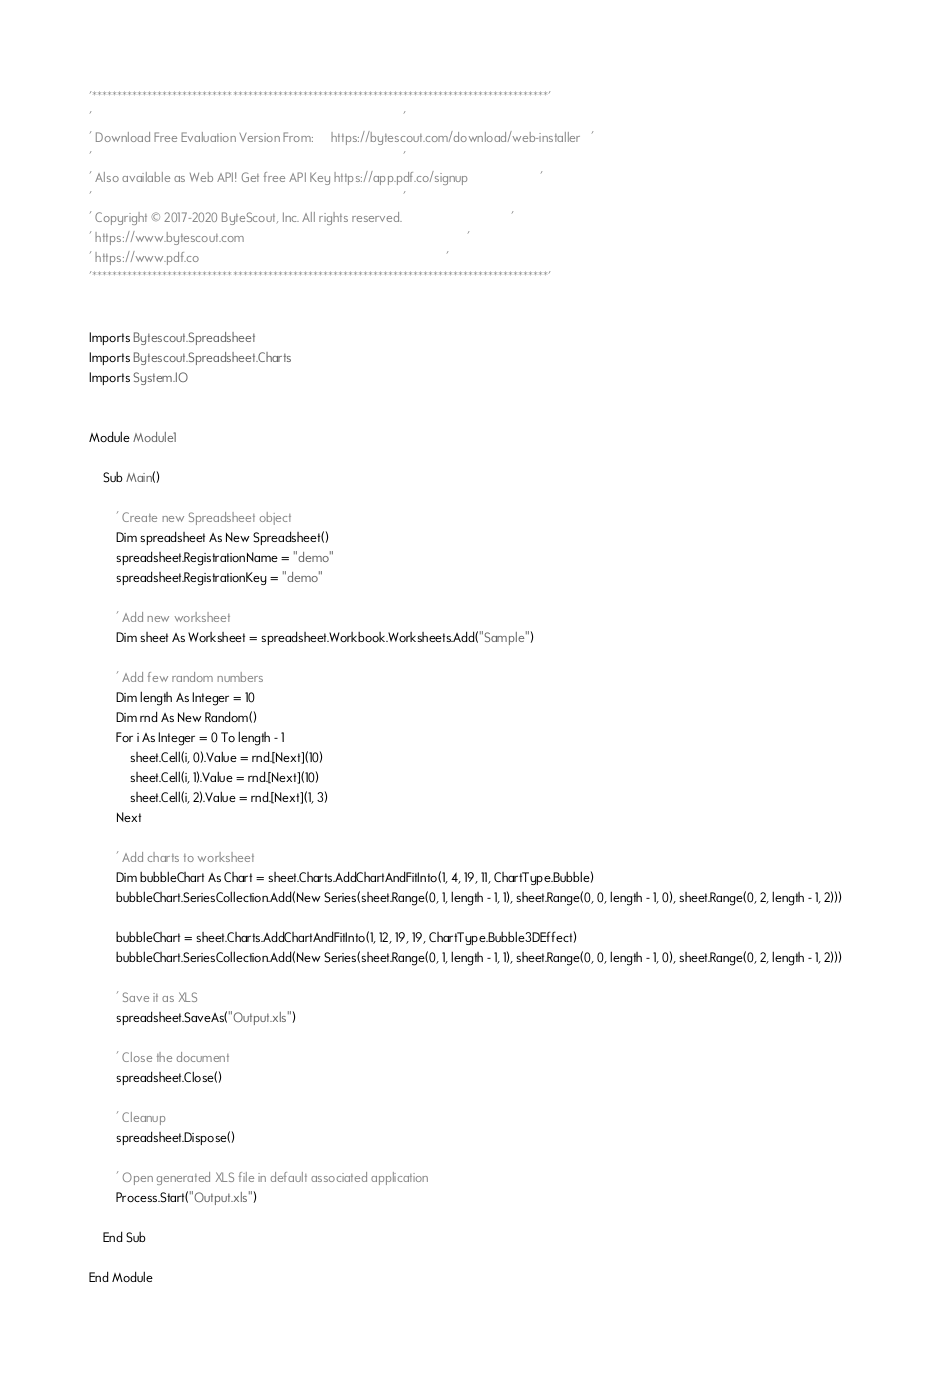Convert code to text. <code><loc_0><loc_0><loc_500><loc_500><_VisualBasic_>'*******************************************************************************************'
'                                                                                           '
' Download Free Evaluation Version From:     https://bytescout.com/download/web-installer   '
'                                                                                           '
' Also available as Web API! Get free API Key https://app.pdf.co/signup                     '
'                                                                                           '
' Copyright © 2017-2020 ByteScout, Inc. All rights reserved.                                '
' https://www.bytescout.com                                                                 '
' https://www.pdf.co                                                                        '
'*******************************************************************************************'


Imports Bytescout.Spreadsheet
Imports Bytescout.Spreadsheet.Charts
Imports System.IO


Module Module1

    Sub Main()

        ' Create new Spreadsheet object
        Dim spreadsheet As New Spreadsheet()
        spreadsheet.RegistrationName = "demo"
        spreadsheet.RegistrationKey = "demo"

        ' Add new worksheet
        Dim sheet As Worksheet = spreadsheet.Workbook.Worksheets.Add("Sample")

        ' Add few random numbers
        Dim length As Integer = 10
        Dim rnd As New Random()
        For i As Integer = 0 To length - 1
            sheet.Cell(i, 0).Value = rnd.[Next](10)
            sheet.Cell(i, 1).Value = rnd.[Next](10)
            sheet.Cell(i, 2).Value = rnd.[Next](1, 3)
        Next

        ' Add charts to worksheet
        Dim bubbleChart As Chart = sheet.Charts.AddChartAndFitInto(1, 4, 19, 11, ChartType.Bubble)
        bubbleChart.SeriesCollection.Add(New Series(sheet.Range(0, 1, length - 1, 1), sheet.Range(0, 0, length - 1, 0), sheet.Range(0, 2, length - 1, 2)))

        bubbleChart = sheet.Charts.AddChartAndFitInto(1, 12, 19, 19, ChartType.Bubble3DEffect)
        bubbleChart.SeriesCollection.Add(New Series(sheet.Range(0, 1, length - 1, 1), sheet.Range(0, 0, length - 1, 0), sheet.Range(0, 2, length - 1, 2)))

        ' Save it as XLS
        spreadsheet.SaveAs("Output.xls")

        ' Close the document
        spreadsheet.Close()

        ' Cleanup
        spreadsheet.Dispose()

        ' Open generated XLS file in default associated application
        Process.Start("Output.xls")

    End Sub

End Module
</code> 